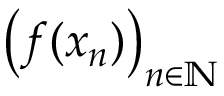Convert formula to latex. <formula><loc_0><loc_0><loc_500><loc_500>\left ( f ( x _ { n } ) \right ) _ { n \in \mathbb { N } }</formula> 